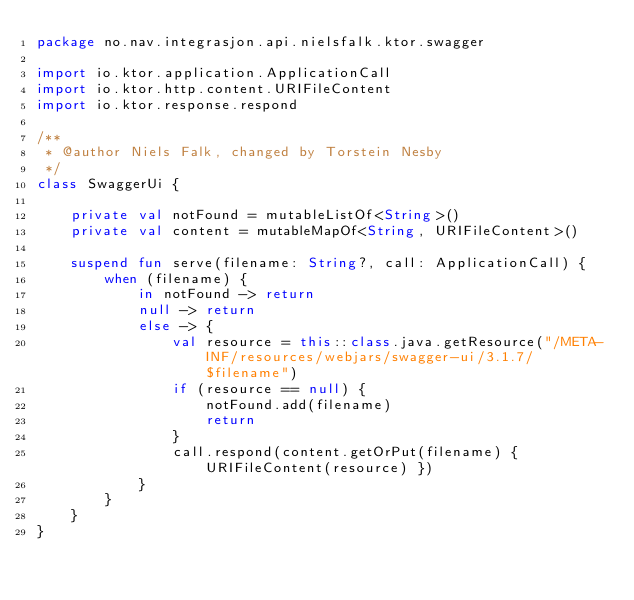<code> <loc_0><loc_0><loc_500><loc_500><_Kotlin_>package no.nav.integrasjon.api.nielsfalk.ktor.swagger

import io.ktor.application.ApplicationCall
import io.ktor.http.content.URIFileContent
import io.ktor.response.respond

/**
 * @author Niels Falk, changed by Torstein Nesby
 */
class SwaggerUi {

    private val notFound = mutableListOf<String>()
    private val content = mutableMapOf<String, URIFileContent>()

    suspend fun serve(filename: String?, call: ApplicationCall) {
        when (filename) {
            in notFound -> return
            null -> return
            else -> {
                val resource = this::class.java.getResource("/META-INF/resources/webjars/swagger-ui/3.1.7/$filename")
                if (resource == null) {
                    notFound.add(filename)
                    return
                }
                call.respond(content.getOrPut(filename) { URIFileContent(resource) })
            }
        }
    }
}
</code> 